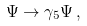Convert formula to latex. <formula><loc_0><loc_0><loc_500><loc_500>\Psi \to \gamma _ { 5 } \Psi \, ,</formula> 